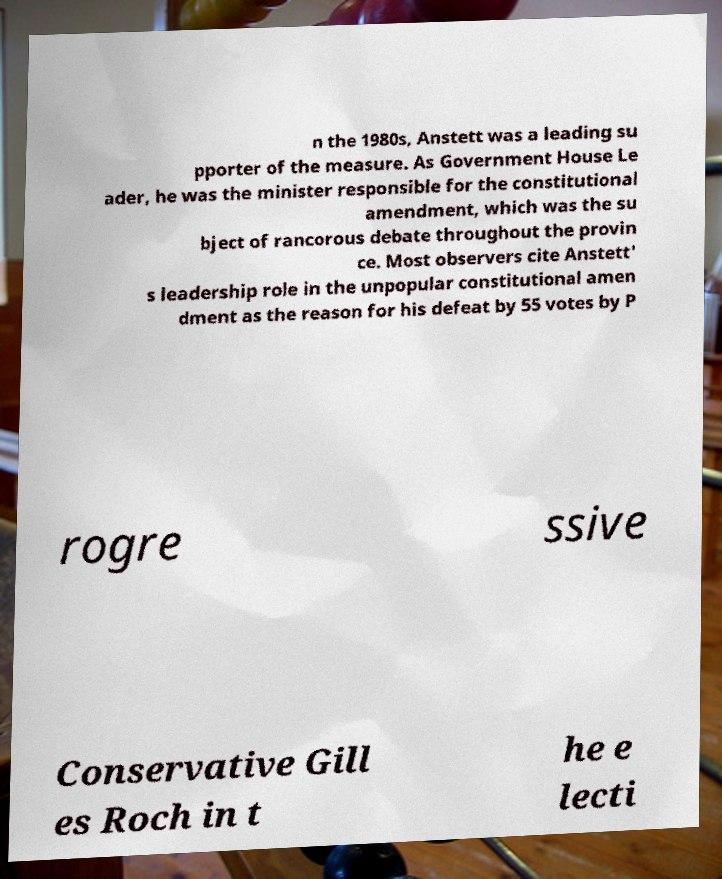Could you extract and type out the text from this image? n the 1980s, Anstett was a leading su pporter of the measure. As Government House Le ader, he was the minister responsible for the constitutional amendment, which was the su bject of rancorous debate throughout the provin ce. Most observers cite Anstett' s leadership role in the unpopular constitutional amen dment as the reason for his defeat by 55 votes by P rogre ssive Conservative Gill es Roch in t he e lecti 